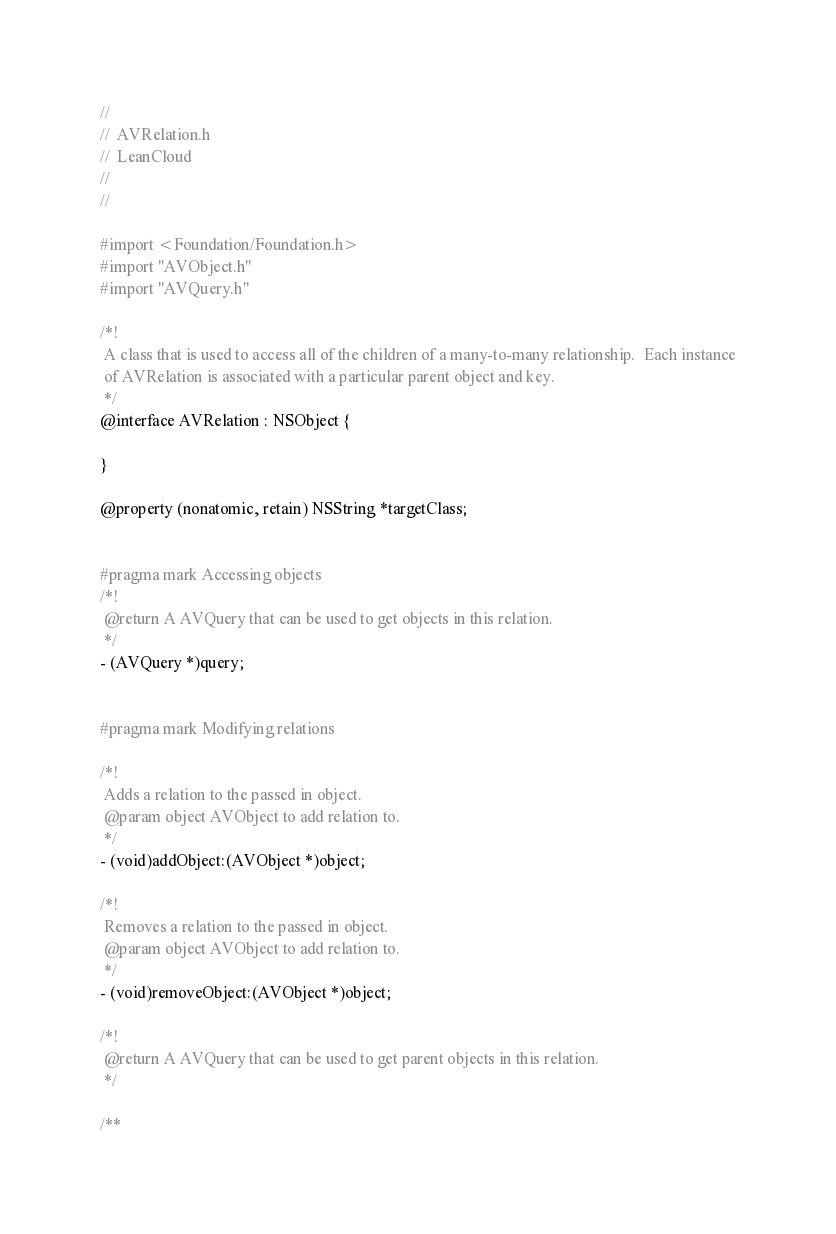Convert code to text. <code><loc_0><loc_0><loc_500><loc_500><_C_>//
//  AVRelation.h
//  LeanCloud
//
//

#import <Foundation/Foundation.h>
#import "AVObject.h"
#import "AVQuery.h"

/*!
 A class that is used to access all of the children of a many-to-many relationship.  Each instance
 of AVRelation is associated with a particular parent object and key.
 */
@interface AVRelation : NSObject {
    
}

@property (nonatomic, retain) NSString *targetClass;


#pragma mark Accessing objects
/*!
 @return A AVQuery that can be used to get objects in this relation.
 */
- (AVQuery *)query;


#pragma mark Modifying relations

/*!
 Adds a relation to the passed in object.
 @param object AVObject to add relation to.
 */
- (void)addObject:(AVObject *)object;

/*!
 Removes a relation to the passed in object.
 @param object AVObject to add relation to.
 */
- (void)removeObject:(AVObject *)object;

/*!
 @return A AVQuery that can be used to get parent objects in this relation.
 */

/**</code> 